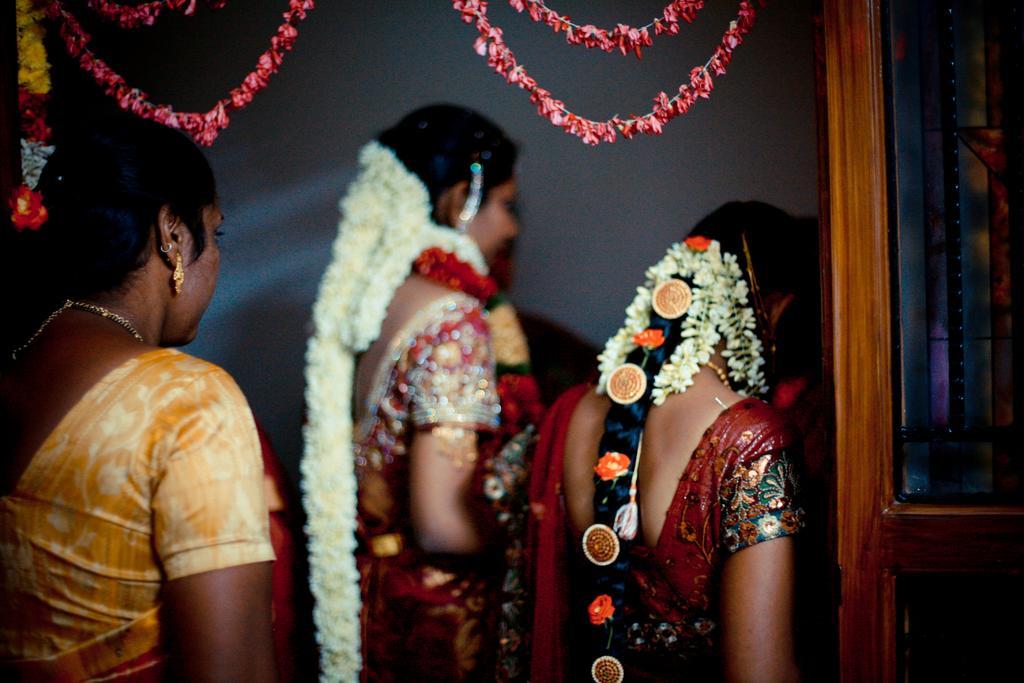How would you summarize this image in a sentence or two? In this picture there are three women wearing sarees with flowers in their heads. All of them are facing backwards. Towards the right, there is a door. On the top, there are garlands. 